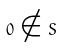Convert formula to latex. <formula><loc_0><loc_0><loc_500><loc_500>0 \notin S</formula> 